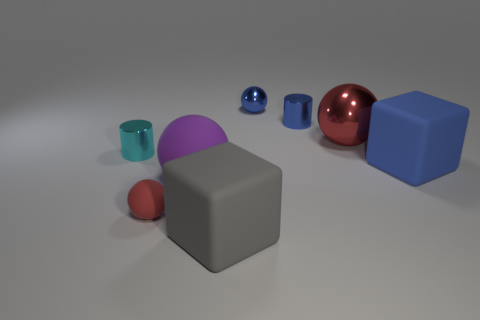What color is the object that is in front of the red object that is left of the large metallic sphere?
Provide a succinct answer. Gray. There is a rubber thing that is the same size as the blue ball; what is its color?
Your answer should be compact. Red. What number of big things are either purple spheres or red shiny objects?
Provide a short and direct response. 2. Is the number of gray rubber objects behind the red matte sphere greater than the number of blue spheres in front of the large gray rubber cube?
Your answer should be compact. No. There is a thing that is the same color as the large shiny sphere; what size is it?
Offer a very short reply. Small. How many other things are the same size as the red matte ball?
Provide a short and direct response. 3. Do the tiny ball to the right of the purple object and the tiny red object have the same material?
Provide a succinct answer. No. How many other objects are the same color as the large matte sphere?
Your response must be concise. 0. How many other objects are there of the same shape as the tiny cyan metal object?
Keep it short and to the point. 1. Is the shape of the blue thing that is in front of the small cyan thing the same as the purple matte thing that is in front of the large shiny ball?
Your answer should be very brief. No. 